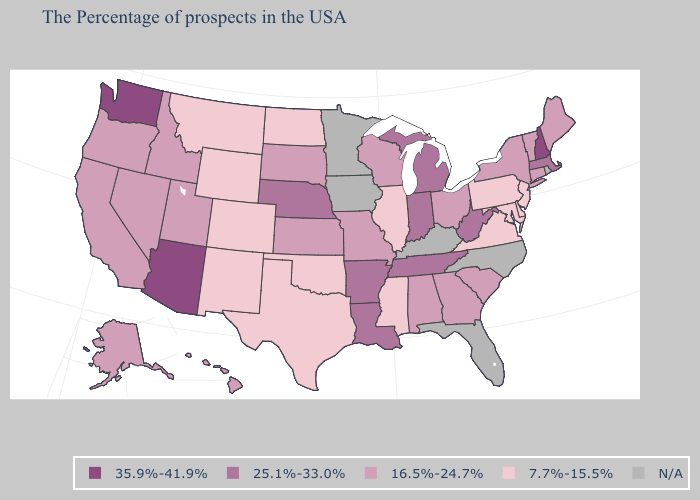Name the states that have a value in the range 7.7%-15.5%?
Concise answer only. New Jersey, Delaware, Maryland, Pennsylvania, Virginia, Illinois, Mississippi, Oklahoma, Texas, North Dakota, Wyoming, Colorado, New Mexico, Montana. Name the states that have a value in the range 16.5%-24.7%?
Keep it brief. Maine, Vermont, Connecticut, New York, South Carolina, Ohio, Georgia, Alabama, Wisconsin, Missouri, Kansas, South Dakota, Utah, Idaho, Nevada, California, Oregon, Alaska, Hawaii. Does Delaware have the highest value in the USA?
Be succinct. No. Does the first symbol in the legend represent the smallest category?
Write a very short answer. No. What is the lowest value in the USA?
Be succinct. 7.7%-15.5%. Name the states that have a value in the range 7.7%-15.5%?
Quick response, please. New Jersey, Delaware, Maryland, Pennsylvania, Virginia, Illinois, Mississippi, Oklahoma, Texas, North Dakota, Wyoming, Colorado, New Mexico, Montana. Name the states that have a value in the range 7.7%-15.5%?
Keep it brief. New Jersey, Delaware, Maryland, Pennsylvania, Virginia, Illinois, Mississippi, Oklahoma, Texas, North Dakota, Wyoming, Colorado, New Mexico, Montana. Does the first symbol in the legend represent the smallest category?
Give a very brief answer. No. Name the states that have a value in the range 16.5%-24.7%?
Write a very short answer. Maine, Vermont, Connecticut, New York, South Carolina, Ohio, Georgia, Alabama, Wisconsin, Missouri, Kansas, South Dakota, Utah, Idaho, Nevada, California, Oregon, Alaska, Hawaii. Name the states that have a value in the range 25.1%-33.0%?
Write a very short answer. Massachusetts, West Virginia, Michigan, Indiana, Tennessee, Louisiana, Arkansas, Nebraska. What is the highest value in the West ?
Answer briefly. 35.9%-41.9%. What is the value of Ohio?
Short answer required. 16.5%-24.7%. What is the highest value in the MidWest ?
Give a very brief answer. 25.1%-33.0%. 